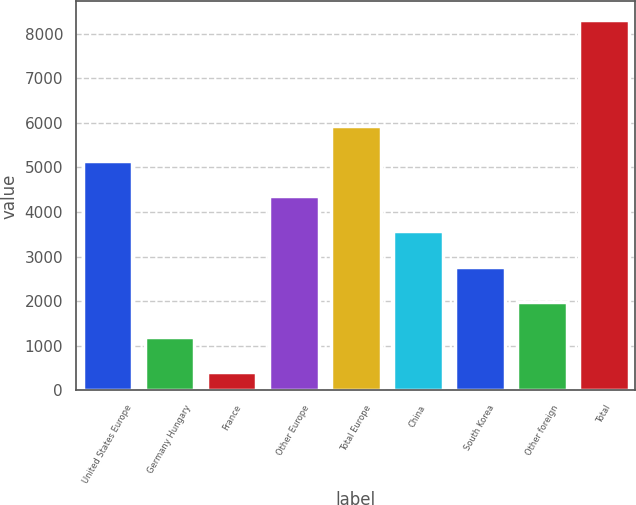<chart> <loc_0><loc_0><loc_500><loc_500><bar_chart><fcel>United States Europe<fcel>Germany Hungary<fcel>France<fcel>Other Europe<fcel>Total Europe<fcel>China<fcel>South Korea<fcel>Other foreign<fcel>Total<nl><fcel>5145.14<fcel>1195.19<fcel>405.2<fcel>4355.15<fcel>5935.13<fcel>3565.16<fcel>2775.17<fcel>1985.18<fcel>8305.1<nl></chart> 